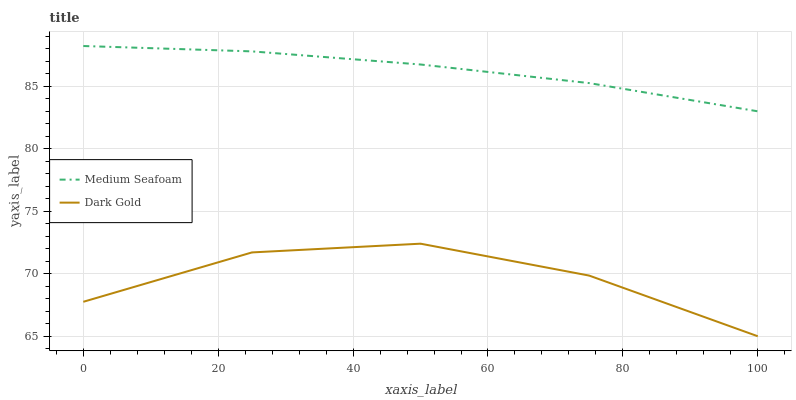Does Dark Gold have the maximum area under the curve?
Answer yes or no. No. Is Dark Gold the smoothest?
Answer yes or no. No. Does Dark Gold have the highest value?
Answer yes or no. No. Is Dark Gold less than Medium Seafoam?
Answer yes or no. Yes. Is Medium Seafoam greater than Dark Gold?
Answer yes or no. Yes. Does Dark Gold intersect Medium Seafoam?
Answer yes or no. No. 